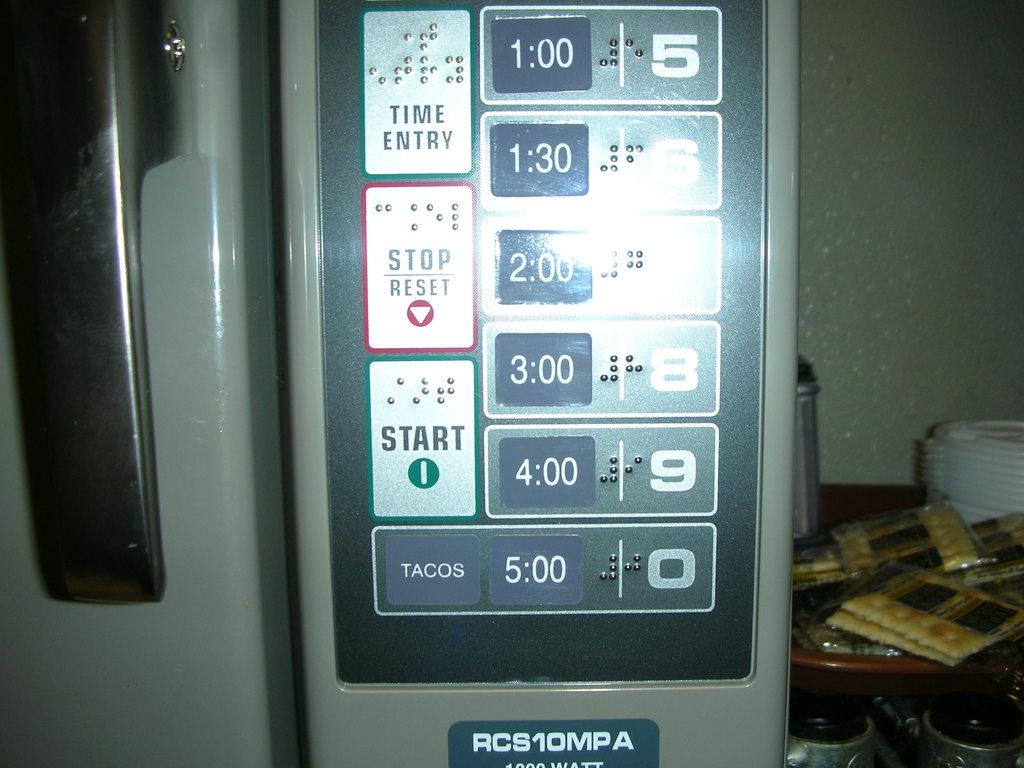What's the first time on the item?
Keep it short and to the point. 1:00. What is the button besides the 5:00 button?
Ensure brevity in your answer.  Tacos. 